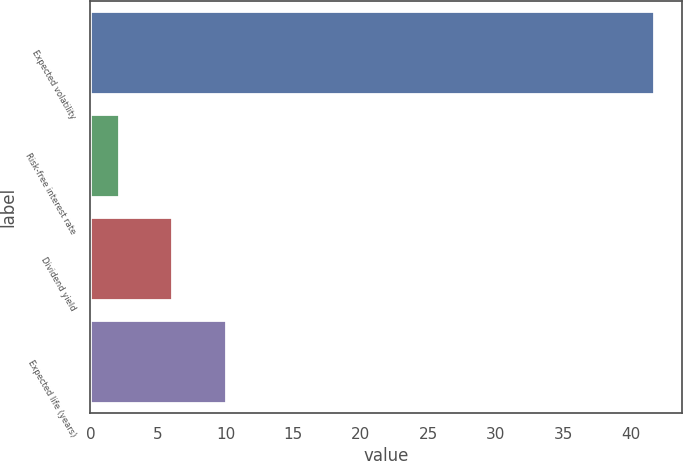<chart> <loc_0><loc_0><loc_500><loc_500><bar_chart><fcel>Expected volatility<fcel>Risk-free interest rate<fcel>Dividend yield<fcel>Expected life (years)<nl><fcel>41.7<fcel>2.1<fcel>6.06<fcel>10.02<nl></chart> 